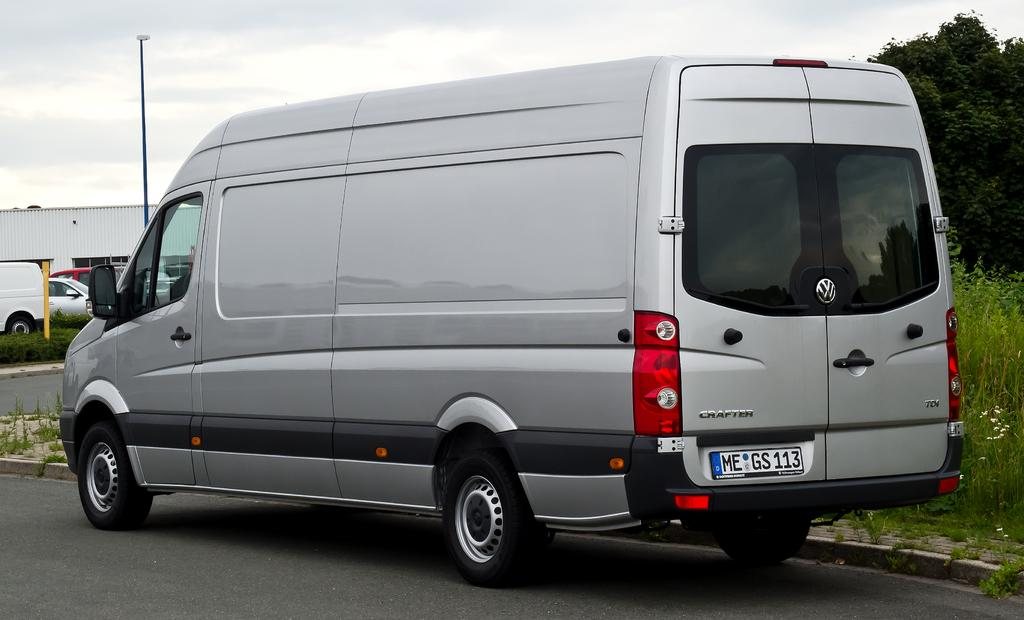<image>
Present a compact description of the photo's key features. A gray Crafter Van sits on the side of the road with a license plate MEGS113. 